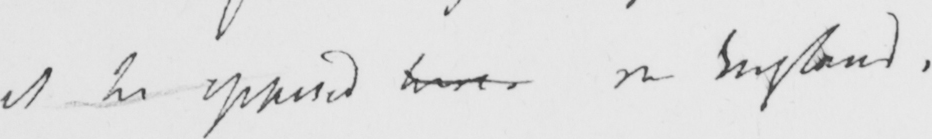Transcribe the text shown in this historical manuscript line. be opposed here in England . 